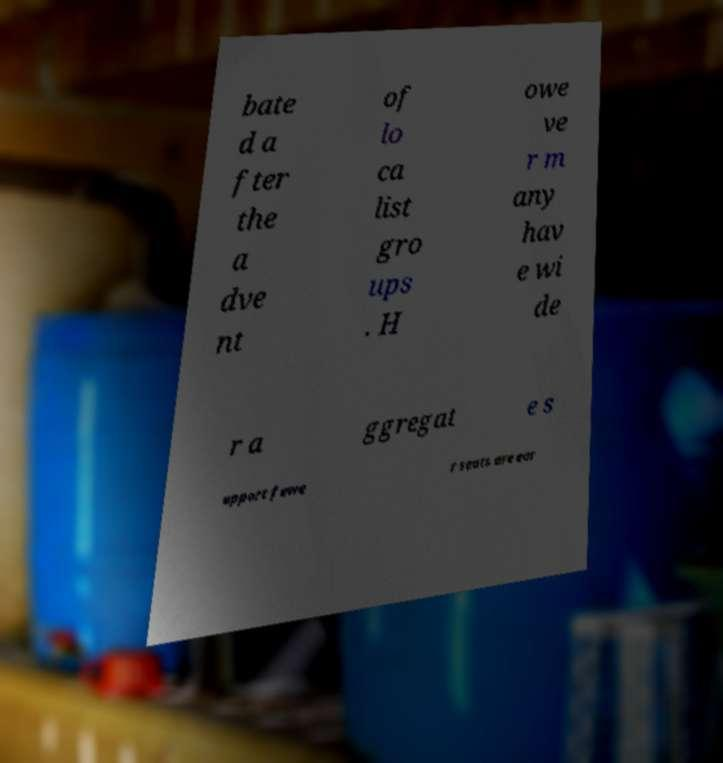Can you read and provide the text displayed in the image?This photo seems to have some interesting text. Can you extract and type it out for me? bate d a fter the a dve nt of lo ca list gro ups . H owe ve r m any hav e wi de r a ggregat e s upport fewe r seats are ear 